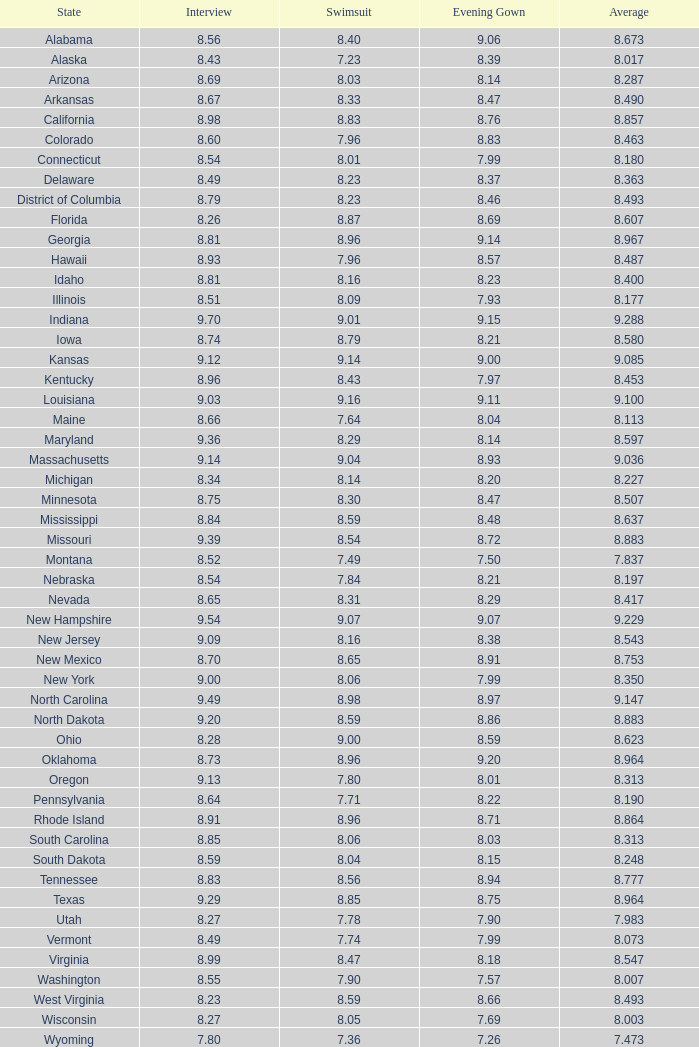What is the total of interviews for evening dress exceeding None. 